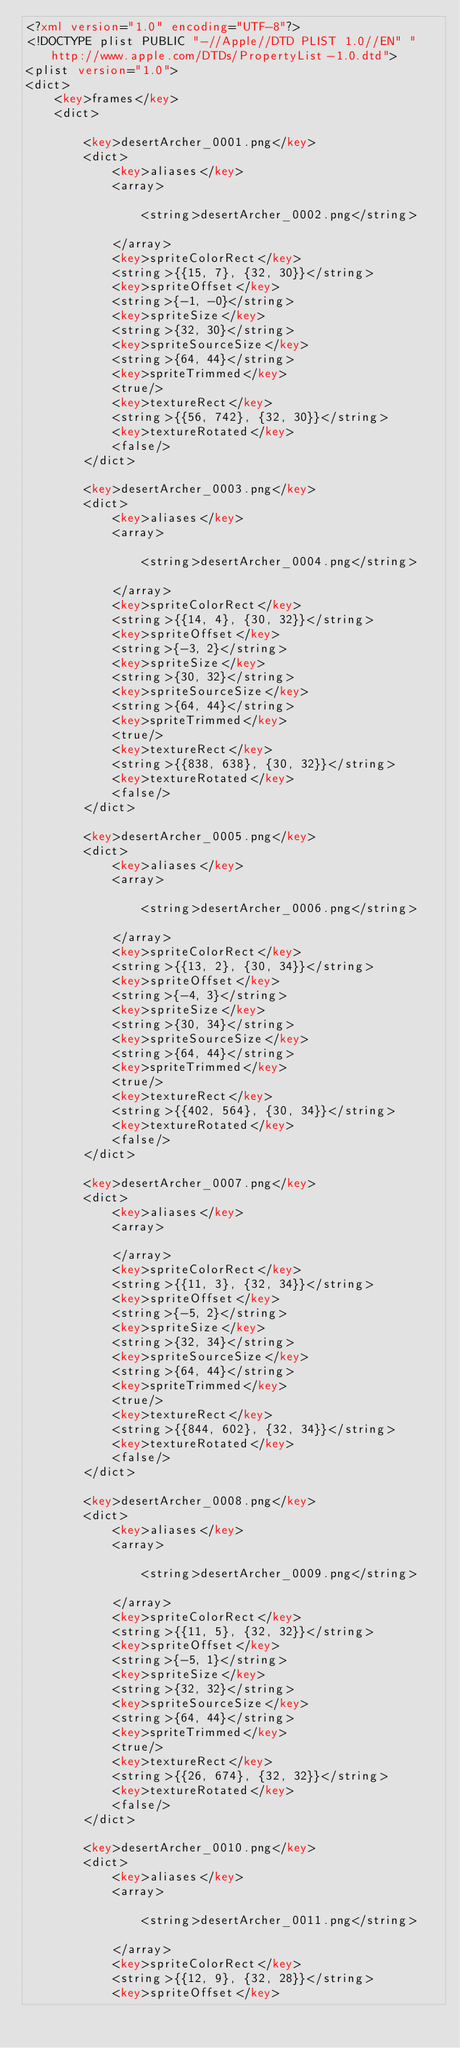Convert code to text. <code><loc_0><loc_0><loc_500><loc_500><_XML_><?xml version="1.0" encoding="UTF-8"?>
<!DOCTYPE plist PUBLIC "-//Apple//DTD PLIST 1.0//EN" "http://www.apple.com/DTDs/PropertyList-1.0.dtd">
<plist version="1.0">
<dict>
	<key>frames</key>
	<dict>
		
		<key>desertArcher_0001.png</key>
		<dict>
			<key>aliases</key>
			<array>
			
				<string>desertArcher_0002.png</string>
			
			</array>
			<key>spriteColorRect</key>
			<string>{{15, 7}, {32, 30}}</string>
			<key>spriteOffset</key>
			<string>{-1, -0}</string>
			<key>spriteSize</key>
			<string>{32, 30}</string>
			<key>spriteSourceSize</key>
			<string>{64, 44}</string>
			<key>spriteTrimmed</key>
			<true/>
			<key>textureRect</key>
			<string>{{56, 742}, {32, 30}}</string>
			<key>textureRotated</key>
			<false/>
		</dict>
		
		<key>desertArcher_0003.png</key>
		<dict>
			<key>aliases</key>
			<array>
			
				<string>desertArcher_0004.png</string>
			
			</array>
			<key>spriteColorRect</key>
			<string>{{14, 4}, {30, 32}}</string>
			<key>spriteOffset</key>
			<string>{-3, 2}</string>
			<key>spriteSize</key>
			<string>{30, 32}</string>
			<key>spriteSourceSize</key>
			<string>{64, 44}</string>
			<key>spriteTrimmed</key>
			<true/>
			<key>textureRect</key>
			<string>{{838, 638}, {30, 32}}</string>
			<key>textureRotated</key>
			<false/>
		</dict>
		
		<key>desertArcher_0005.png</key>
		<dict>
			<key>aliases</key>
			<array>
			
				<string>desertArcher_0006.png</string>
			
			</array>
			<key>spriteColorRect</key>
			<string>{{13, 2}, {30, 34}}</string>
			<key>spriteOffset</key>
			<string>{-4, 3}</string>
			<key>spriteSize</key>
			<string>{30, 34}</string>
			<key>spriteSourceSize</key>
			<string>{64, 44}</string>
			<key>spriteTrimmed</key>
			<true/>
			<key>textureRect</key>
			<string>{{402, 564}, {30, 34}}</string>
			<key>textureRotated</key>
			<false/>
		</dict>
		
		<key>desertArcher_0007.png</key>
		<dict>
			<key>aliases</key>
			<array>
			
			</array>
			<key>spriteColorRect</key>
			<string>{{11, 3}, {32, 34}}</string>
			<key>spriteOffset</key>
			<string>{-5, 2}</string>
			<key>spriteSize</key>
			<string>{32, 34}</string>
			<key>spriteSourceSize</key>
			<string>{64, 44}</string>
			<key>spriteTrimmed</key>
			<true/>
			<key>textureRect</key>
			<string>{{844, 602}, {32, 34}}</string>
			<key>textureRotated</key>
			<false/>
		</dict>
		
		<key>desertArcher_0008.png</key>
		<dict>
			<key>aliases</key>
			<array>
			
				<string>desertArcher_0009.png</string>
			
			</array>
			<key>spriteColorRect</key>
			<string>{{11, 5}, {32, 32}}</string>
			<key>spriteOffset</key>
			<string>{-5, 1}</string>
			<key>spriteSize</key>
			<string>{32, 32}</string>
			<key>spriteSourceSize</key>
			<string>{64, 44}</string>
			<key>spriteTrimmed</key>
			<true/>
			<key>textureRect</key>
			<string>{{26, 674}, {32, 32}}</string>
			<key>textureRotated</key>
			<false/>
		</dict>
		
		<key>desertArcher_0010.png</key>
		<dict>
			<key>aliases</key>
			<array>
			
				<string>desertArcher_0011.png</string>
			
			</array>
			<key>spriteColorRect</key>
			<string>{{12, 9}, {32, 28}}</string>
			<key>spriteOffset</key></code> 